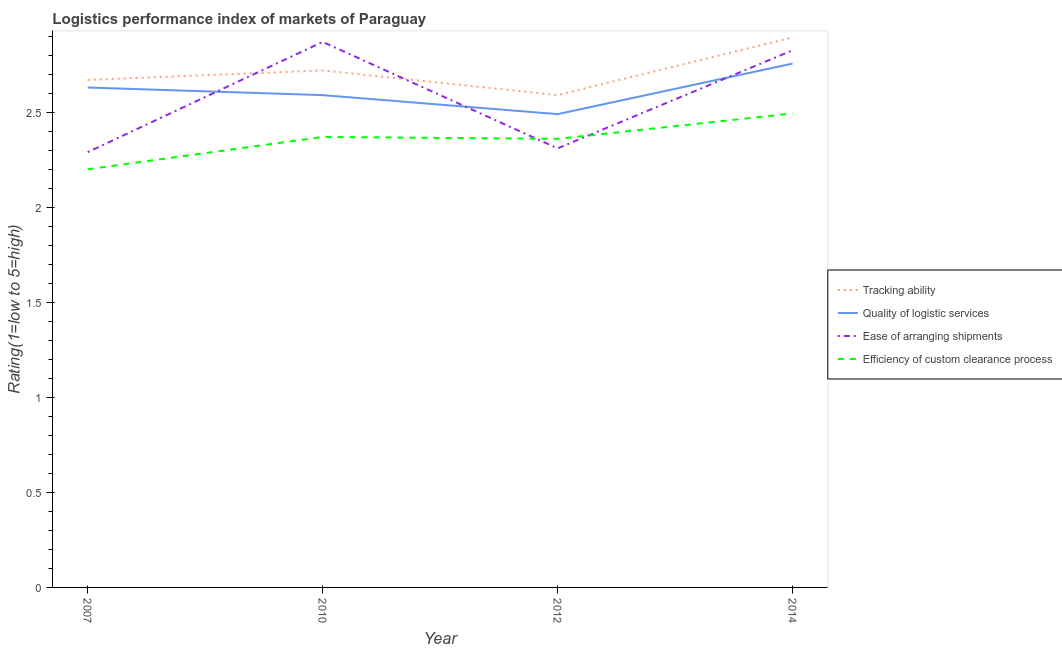Does the line corresponding to lpi rating of quality of logistic services intersect with the line corresponding to lpi rating of efficiency of custom clearance process?
Provide a succinct answer. No. What is the lpi rating of quality of logistic services in 2010?
Your answer should be very brief. 2.59. Across all years, what is the maximum lpi rating of efficiency of custom clearance process?
Your response must be concise. 2.49. Across all years, what is the minimum lpi rating of tracking ability?
Ensure brevity in your answer.  2.59. In which year was the lpi rating of ease of arranging shipments minimum?
Ensure brevity in your answer.  2007. What is the total lpi rating of quality of logistic services in the graph?
Your response must be concise. 10.47. What is the difference between the lpi rating of ease of arranging shipments in 2010 and that in 2014?
Offer a terse response. 0.04. What is the difference between the lpi rating of quality of logistic services in 2014 and the lpi rating of tracking ability in 2007?
Provide a succinct answer. 0.09. What is the average lpi rating of quality of logistic services per year?
Provide a succinct answer. 2.62. In the year 2007, what is the difference between the lpi rating of tracking ability and lpi rating of ease of arranging shipments?
Provide a short and direct response. 0.38. In how many years, is the lpi rating of efficiency of custom clearance process greater than 2.6?
Ensure brevity in your answer.  0. What is the ratio of the lpi rating of ease of arranging shipments in 2010 to that in 2012?
Make the answer very short. 1.24. What is the difference between the highest and the second highest lpi rating of ease of arranging shipments?
Ensure brevity in your answer.  0.04. What is the difference between the highest and the lowest lpi rating of ease of arranging shipments?
Your response must be concise. 0.58. In how many years, is the lpi rating of quality of logistic services greater than the average lpi rating of quality of logistic services taken over all years?
Offer a very short reply. 2. Does the lpi rating of quality of logistic services monotonically increase over the years?
Ensure brevity in your answer.  No. Is the lpi rating of ease of arranging shipments strictly less than the lpi rating of tracking ability over the years?
Offer a terse response. No. How many lines are there?
Provide a short and direct response. 4. What is the difference between two consecutive major ticks on the Y-axis?
Your answer should be compact. 0.5. Are the values on the major ticks of Y-axis written in scientific E-notation?
Make the answer very short. No. Where does the legend appear in the graph?
Offer a very short reply. Center right. What is the title of the graph?
Offer a terse response. Logistics performance index of markets of Paraguay. What is the label or title of the Y-axis?
Provide a succinct answer. Rating(1=low to 5=high). What is the Rating(1=low to 5=high) in Tracking ability in 2007?
Make the answer very short. 2.67. What is the Rating(1=low to 5=high) of Quality of logistic services in 2007?
Offer a very short reply. 2.63. What is the Rating(1=low to 5=high) of Ease of arranging shipments in 2007?
Your answer should be compact. 2.29. What is the Rating(1=low to 5=high) of Efficiency of custom clearance process in 2007?
Keep it short and to the point. 2.2. What is the Rating(1=low to 5=high) of Tracking ability in 2010?
Your answer should be very brief. 2.72. What is the Rating(1=low to 5=high) in Quality of logistic services in 2010?
Make the answer very short. 2.59. What is the Rating(1=low to 5=high) in Ease of arranging shipments in 2010?
Provide a short and direct response. 2.87. What is the Rating(1=low to 5=high) of Efficiency of custom clearance process in 2010?
Ensure brevity in your answer.  2.37. What is the Rating(1=low to 5=high) in Tracking ability in 2012?
Provide a short and direct response. 2.59. What is the Rating(1=low to 5=high) of Quality of logistic services in 2012?
Offer a terse response. 2.49. What is the Rating(1=low to 5=high) in Ease of arranging shipments in 2012?
Provide a short and direct response. 2.31. What is the Rating(1=low to 5=high) in Efficiency of custom clearance process in 2012?
Make the answer very short. 2.36. What is the Rating(1=low to 5=high) of Tracking ability in 2014?
Keep it short and to the point. 2.89. What is the Rating(1=low to 5=high) in Quality of logistic services in 2014?
Your response must be concise. 2.76. What is the Rating(1=low to 5=high) of Ease of arranging shipments in 2014?
Your answer should be compact. 2.83. What is the Rating(1=low to 5=high) in Efficiency of custom clearance process in 2014?
Keep it short and to the point. 2.49. Across all years, what is the maximum Rating(1=low to 5=high) of Tracking ability?
Keep it short and to the point. 2.89. Across all years, what is the maximum Rating(1=low to 5=high) in Quality of logistic services?
Give a very brief answer. 2.76. Across all years, what is the maximum Rating(1=low to 5=high) in Ease of arranging shipments?
Ensure brevity in your answer.  2.87. Across all years, what is the maximum Rating(1=low to 5=high) in Efficiency of custom clearance process?
Provide a succinct answer. 2.49. Across all years, what is the minimum Rating(1=low to 5=high) of Tracking ability?
Provide a short and direct response. 2.59. Across all years, what is the minimum Rating(1=low to 5=high) of Quality of logistic services?
Provide a short and direct response. 2.49. Across all years, what is the minimum Rating(1=low to 5=high) of Ease of arranging shipments?
Your answer should be compact. 2.29. What is the total Rating(1=low to 5=high) in Tracking ability in the graph?
Provide a succinct answer. 10.87. What is the total Rating(1=low to 5=high) in Quality of logistic services in the graph?
Provide a short and direct response. 10.47. What is the total Rating(1=low to 5=high) in Ease of arranging shipments in the graph?
Your response must be concise. 10.3. What is the total Rating(1=low to 5=high) in Efficiency of custom clearance process in the graph?
Your answer should be very brief. 9.42. What is the difference between the Rating(1=low to 5=high) of Tracking ability in 2007 and that in 2010?
Ensure brevity in your answer.  -0.05. What is the difference between the Rating(1=low to 5=high) of Quality of logistic services in 2007 and that in 2010?
Give a very brief answer. 0.04. What is the difference between the Rating(1=low to 5=high) of Ease of arranging shipments in 2007 and that in 2010?
Your response must be concise. -0.58. What is the difference between the Rating(1=low to 5=high) of Efficiency of custom clearance process in 2007 and that in 2010?
Your answer should be very brief. -0.17. What is the difference between the Rating(1=low to 5=high) of Quality of logistic services in 2007 and that in 2012?
Your answer should be very brief. 0.14. What is the difference between the Rating(1=low to 5=high) of Ease of arranging shipments in 2007 and that in 2012?
Keep it short and to the point. -0.02. What is the difference between the Rating(1=low to 5=high) of Efficiency of custom clearance process in 2007 and that in 2012?
Ensure brevity in your answer.  -0.16. What is the difference between the Rating(1=low to 5=high) in Tracking ability in 2007 and that in 2014?
Give a very brief answer. -0.22. What is the difference between the Rating(1=low to 5=high) in Quality of logistic services in 2007 and that in 2014?
Provide a succinct answer. -0.13. What is the difference between the Rating(1=low to 5=high) in Ease of arranging shipments in 2007 and that in 2014?
Offer a very short reply. -0.54. What is the difference between the Rating(1=low to 5=high) of Efficiency of custom clearance process in 2007 and that in 2014?
Offer a terse response. -0.29. What is the difference between the Rating(1=low to 5=high) of Tracking ability in 2010 and that in 2012?
Keep it short and to the point. 0.13. What is the difference between the Rating(1=low to 5=high) in Ease of arranging shipments in 2010 and that in 2012?
Your answer should be compact. 0.56. What is the difference between the Rating(1=low to 5=high) of Efficiency of custom clearance process in 2010 and that in 2012?
Keep it short and to the point. 0.01. What is the difference between the Rating(1=low to 5=high) in Tracking ability in 2010 and that in 2014?
Your response must be concise. -0.17. What is the difference between the Rating(1=low to 5=high) in Quality of logistic services in 2010 and that in 2014?
Keep it short and to the point. -0.17. What is the difference between the Rating(1=low to 5=high) of Ease of arranging shipments in 2010 and that in 2014?
Your response must be concise. 0.04. What is the difference between the Rating(1=low to 5=high) of Efficiency of custom clearance process in 2010 and that in 2014?
Offer a very short reply. -0.12. What is the difference between the Rating(1=low to 5=high) of Tracking ability in 2012 and that in 2014?
Offer a very short reply. -0.3. What is the difference between the Rating(1=low to 5=high) in Quality of logistic services in 2012 and that in 2014?
Your answer should be very brief. -0.27. What is the difference between the Rating(1=low to 5=high) of Ease of arranging shipments in 2012 and that in 2014?
Provide a succinct answer. -0.52. What is the difference between the Rating(1=low to 5=high) in Efficiency of custom clearance process in 2012 and that in 2014?
Ensure brevity in your answer.  -0.13. What is the difference between the Rating(1=low to 5=high) of Tracking ability in 2007 and the Rating(1=low to 5=high) of Efficiency of custom clearance process in 2010?
Give a very brief answer. 0.3. What is the difference between the Rating(1=low to 5=high) of Quality of logistic services in 2007 and the Rating(1=low to 5=high) of Ease of arranging shipments in 2010?
Give a very brief answer. -0.24. What is the difference between the Rating(1=low to 5=high) of Quality of logistic services in 2007 and the Rating(1=low to 5=high) of Efficiency of custom clearance process in 2010?
Ensure brevity in your answer.  0.26. What is the difference between the Rating(1=low to 5=high) in Ease of arranging shipments in 2007 and the Rating(1=low to 5=high) in Efficiency of custom clearance process in 2010?
Give a very brief answer. -0.08. What is the difference between the Rating(1=low to 5=high) of Tracking ability in 2007 and the Rating(1=low to 5=high) of Quality of logistic services in 2012?
Your answer should be compact. 0.18. What is the difference between the Rating(1=low to 5=high) in Tracking ability in 2007 and the Rating(1=low to 5=high) in Ease of arranging shipments in 2012?
Your answer should be compact. 0.36. What is the difference between the Rating(1=low to 5=high) of Tracking ability in 2007 and the Rating(1=low to 5=high) of Efficiency of custom clearance process in 2012?
Make the answer very short. 0.31. What is the difference between the Rating(1=low to 5=high) of Quality of logistic services in 2007 and the Rating(1=low to 5=high) of Ease of arranging shipments in 2012?
Offer a terse response. 0.32. What is the difference between the Rating(1=low to 5=high) of Quality of logistic services in 2007 and the Rating(1=low to 5=high) of Efficiency of custom clearance process in 2012?
Offer a very short reply. 0.27. What is the difference between the Rating(1=low to 5=high) of Ease of arranging shipments in 2007 and the Rating(1=low to 5=high) of Efficiency of custom clearance process in 2012?
Your answer should be very brief. -0.07. What is the difference between the Rating(1=low to 5=high) in Tracking ability in 2007 and the Rating(1=low to 5=high) in Quality of logistic services in 2014?
Provide a succinct answer. -0.09. What is the difference between the Rating(1=low to 5=high) in Tracking ability in 2007 and the Rating(1=low to 5=high) in Ease of arranging shipments in 2014?
Your response must be concise. -0.16. What is the difference between the Rating(1=low to 5=high) in Tracking ability in 2007 and the Rating(1=low to 5=high) in Efficiency of custom clearance process in 2014?
Provide a succinct answer. 0.18. What is the difference between the Rating(1=low to 5=high) of Quality of logistic services in 2007 and the Rating(1=low to 5=high) of Ease of arranging shipments in 2014?
Keep it short and to the point. -0.2. What is the difference between the Rating(1=low to 5=high) of Quality of logistic services in 2007 and the Rating(1=low to 5=high) of Efficiency of custom clearance process in 2014?
Offer a terse response. 0.14. What is the difference between the Rating(1=low to 5=high) in Ease of arranging shipments in 2007 and the Rating(1=low to 5=high) in Efficiency of custom clearance process in 2014?
Offer a very short reply. -0.2. What is the difference between the Rating(1=low to 5=high) in Tracking ability in 2010 and the Rating(1=low to 5=high) in Quality of logistic services in 2012?
Your answer should be compact. 0.23. What is the difference between the Rating(1=low to 5=high) in Tracking ability in 2010 and the Rating(1=low to 5=high) in Ease of arranging shipments in 2012?
Make the answer very short. 0.41. What is the difference between the Rating(1=low to 5=high) of Tracking ability in 2010 and the Rating(1=low to 5=high) of Efficiency of custom clearance process in 2012?
Offer a very short reply. 0.36. What is the difference between the Rating(1=low to 5=high) of Quality of logistic services in 2010 and the Rating(1=low to 5=high) of Ease of arranging shipments in 2012?
Provide a short and direct response. 0.28. What is the difference between the Rating(1=low to 5=high) in Quality of logistic services in 2010 and the Rating(1=low to 5=high) in Efficiency of custom clearance process in 2012?
Offer a very short reply. 0.23. What is the difference between the Rating(1=low to 5=high) in Ease of arranging shipments in 2010 and the Rating(1=low to 5=high) in Efficiency of custom clearance process in 2012?
Provide a succinct answer. 0.51. What is the difference between the Rating(1=low to 5=high) of Tracking ability in 2010 and the Rating(1=low to 5=high) of Quality of logistic services in 2014?
Your response must be concise. -0.04. What is the difference between the Rating(1=low to 5=high) of Tracking ability in 2010 and the Rating(1=low to 5=high) of Ease of arranging shipments in 2014?
Make the answer very short. -0.11. What is the difference between the Rating(1=low to 5=high) in Tracking ability in 2010 and the Rating(1=low to 5=high) in Efficiency of custom clearance process in 2014?
Your response must be concise. 0.23. What is the difference between the Rating(1=low to 5=high) in Quality of logistic services in 2010 and the Rating(1=low to 5=high) in Ease of arranging shipments in 2014?
Provide a short and direct response. -0.24. What is the difference between the Rating(1=low to 5=high) in Quality of logistic services in 2010 and the Rating(1=low to 5=high) in Efficiency of custom clearance process in 2014?
Ensure brevity in your answer.  0.1. What is the difference between the Rating(1=low to 5=high) in Ease of arranging shipments in 2010 and the Rating(1=low to 5=high) in Efficiency of custom clearance process in 2014?
Ensure brevity in your answer.  0.38. What is the difference between the Rating(1=low to 5=high) of Tracking ability in 2012 and the Rating(1=low to 5=high) of Quality of logistic services in 2014?
Ensure brevity in your answer.  -0.17. What is the difference between the Rating(1=low to 5=high) in Tracking ability in 2012 and the Rating(1=low to 5=high) in Ease of arranging shipments in 2014?
Give a very brief answer. -0.24. What is the difference between the Rating(1=low to 5=high) in Tracking ability in 2012 and the Rating(1=low to 5=high) in Efficiency of custom clearance process in 2014?
Keep it short and to the point. 0.1. What is the difference between the Rating(1=low to 5=high) in Quality of logistic services in 2012 and the Rating(1=low to 5=high) in Ease of arranging shipments in 2014?
Offer a terse response. -0.34. What is the difference between the Rating(1=low to 5=high) in Quality of logistic services in 2012 and the Rating(1=low to 5=high) in Efficiency of custom clearance process in 2014?
Offer a terse response. -0. What is the difference between the Rating(1=low to 5=high) of Ease of arranging shipments in 2012 and the Rating(1=low to 5=high) of Efficiency of custom clearance process in 2014?
Offer a terse response. -0.18. What is the average Rating(1=low to 5=high) of Tracking ability per year?
Your answer should be very brief. 2.72. What is the average Rating(1=low to 5=high) in Quality of logistic services per year?
Your response must be concise. 2.62. What is the average Rating(1=low to 5=high) of Ease of arranging shipments per year?
Provide a succinct answer. 2.57. What is the average Rating(1=low to 5=high) in Efficiency of custom clearance process per year?
Keep it short and to the point. 2.36. In the year 2007, what is the difference between the Rating(1=low to 5=high) in Tracking ability and Rating(1=low to 5=high) in Quality of logistic services?
Ensure brevity in your answer.  0.04. In the year 2007, what is the difference between the Rating(1=low to 5=high) in Tracking ability and Rating(1=low to 5=high) in Ease of arranging shipments?
Your response must be concise. 0.38. In the year 2007, what is the difference between the Rating(1=low to 5=high) of Tracking ability and Rating(1=low to 5=high) of Efficiency of custom clearance process?
Keep it short and to the point. 0.47. In the year 2007, what is the difference between the Rating(1=low to 5=high) of Quality of logistic services and Rating(1=low to 5=high) of Ease of arranging shipments?
Make the answer very short. 0.34. In the year 2007, what is the difference between the Rating(1=low to 5=high) of Quality of logistic services and Rating(1=low to 5=high) of Efficiency of custom clearance process?
Offer a terse response. 0.43. In the year 2007, what is the difference between the Rating(1=low to 5=high) of Ease of arranging shipments and Rating(1=low to 5=high) of Efficiency of custom clearance process?
Provide a short and direct response. 0.09. In the year 2010, what is the difference between the Rating(1=low to 5=high) in Tracking ability and Rating(1=low to 5=high) in Quality of logistic services?
Offer a very short reply. 0.13. In the year 2010, what is the difference between the Rating(1=low to 5=high) in Tracking ability and Rating(1=low to 5=high) in Efficiency of custom clearance process?
Ensure brevity in your answer.  0.35. In the year 2010, what is the difference between the Rating(1=low to 5=high) of Quality of logistic services and Rating(1=low to 5=high) of Ease of arranging shipments?
Offer a terse response. -0.28. In the year 2010, what is the difference between the Rating(1=low to 5=high) in Quality of logistic services and Rating(1=low to 5=high) in Efficiency of custom clearance process?
Offer a terse response. 0.22. In the year 2012, what is the difference between the Rating(1=low to 5=high) of Tracking ability and Rating(1=low to 5=high) of Quality of logistic services?
Your answer should be compact. 0.1. In the year 2012, what is the difference between the Rating(1=low to 5=high) of Tracking ability and Rating(1=low to 5=high) of Ease of arranging shipments?
Give a very brief answer. 0.28. In the year 2012, what is the difference between the Rating(1=low to 5=high) of Tracking ability and Rating(1=low to 5=high) of Efficiency of custom clearance process?
Provide a succinct answer. 0.23. In the year 2012, what is the difference between the Rating(1=low to 5=high) in Quality of logistic services and Rating(1=low to 5=high) in Ease of arranging shipments?
Your answer should be compact. 0.18. In the year 2012, what is the difference between the Rating(1=low to 5=high) of Quality of logistic services and Rating(1=low to 5=high) of Efficiency of custom clearance process?
Give a very brief answer. 0.13. In the year 2012, what is the difference between the Rating(1=low to 5=high) of Ease of arranging shipments and Rating(1=low to 5=high) of Efficiency of custom clearance process?
Give a very brief answer. -0.05. In the year 2014, what is the difference between the Rating(1=low to 5=high) in Tracking ability and Rating(1=low to 5=high) in Quality of logistic services?
Offer a terse response. 0.14. In the year 2014, what is the difference between the Rating(1=low to 5=high) in Tracking ability and Rating(1=low to 5=high) in Ease of arranging shipments?
Offer a very short reply. 0.07. In the year 2014, what is the difference between the Rating(1=low to 5=high) in Quality of logistic services and Rating(1=low to 5=high) in Ease of arranging shipments?
Give a very brief answer. -0.07. In the year 2014, what is the difference between the Rating(1=low to 5=high) of Quality of logistic services and Rating(1=low to 5=high) of Efficiency of custom clearance process?
Your answer should be compact. 0.26. In the year 2014, what is the difference between the Rating(1=low to 5=high) of Ease of arranging shipments and Rating(1=low to 5=high) of Efficiency of custom clearance process?
Make the answer very short. 0.33. What is the ratio of the Rating(1=low to 5=high) in Tracking ability in 2007 to that in 2010?
Provide a succinct answer. 0.98. What is the ratio of the Rating(1=low to 5=high) in Quality of logistic services in 2007 to that in 2010?
Provide a succinct answer. 1.02. What is the ratio of the Rating(1=low to 5=high) of Ease of arranging shipments in 2007 to that in 2010?
Keep it short and to the point. 0.8. What is the ratio of the Rating(1=low to 5=high) in Efficiency of custom clearance process in 2007 to that in 2010?
Keep it short and to the point. 0.93. What is the ratio of the Rating(1=low to 5=high) in Tracking ability in 2007 to that in 2012?
Provide a succinct answer. 1.03. What is the ratio of the Rating(1=low to 5=high) of Quality of logistic services in 2007 to that in 2012?
Provide a short and direct response. 1.06. What is the ratio of the Rating(1=low to 5=high) in Efficiency of custom clearance process in 2007 to that in 2012?
Your answer should be compact. 0.93. What is the ratio of the Rating(1=low to 5=high) of Tracking ability in 2007 to that in 2014?
Make the answer very short. 0.92. What is the ratio of the Rating(1=low to 5=high) in Quality of logistic services in 2007 to that in 2014?
Ensure brevity in your answer.  0.95. What is the ratio of the Rating(1=low to 5=high) in Ease of arranging shipments in 2007 to that in 2014?
Offer a terse response. 0.81. What is the ratio of the Rating(1=low to 5=high) of Efficiency of custom clearance process in 2007 to that in 2014?
Keep it short and to the point. 0.88. What is the ratio of the Rating(1=low to 5=high) in Tracking ability in 2010 to that in 2012?
Provide a short and direct response. 1.05. What is the ratio of the Rating(1=low to 5=high) of Quality of logistic services in 2010 to that in 2012?
Your response must be concise. 1.04. What is the ratio of the Rating(1=low to 5=high) of Ease of arranging shipments in 2010 to that in 2012?
Offer a terse response. 1.24. What is the ratio of the Rating(1=low to 5=high) in Efficiency of custom clearance process in 2010 to that in 2012?
Provide a short and direct response. 1. What is the ratio of the Rating(1=low to 5=high) in Quality of logistic services in 2010 to that in 2014?
Keep it short and to the point. 0.94. What is the ratio of the Rating(1=low to 5=high) of Ease of arranging shipments in 2010 to that in 2014?
Provide a succinct answer. 1.02. What is the ratio of the Rating(1=low to 5=high) of Efficiency of custom clearance process in 2010 to that in 2014?
Provide a succinct answer. 0.95. What is the ratio of the Rating(1=low to 5=high) in Tracking ability in 2012 to that in 2014?
Offer a very short reply. 0.9. What is the ratio of the Rating(1=low to 5=high) in Quality of logistic services in 2012 to that in 2014?
Provide a short and direct response. 0.9. What is the ratio of the Rating(1=low to 5=high) in Ease of arranging shipments in 2012 to that in 2014?
Your response must be concise. 0.82. What is the ratio of the Rating(1=low to 5=high) of Efficiency of custom clearance process in 2012 to that in 2014?
Ensure brevity in your answer.  0.95. What is the difference between the highest and the second highest Rating(1=low to 5=high) in Tracking ability?
Provide a succinct answer. 0.17. What is the difference between the highest and the second highest Rating(1=low to 5=high) in Quality of logistic services?
Your answer should be very brief. 0.13. What is the difference between the highest and the second highest Rating(1=low to 5=high) in Ease of arranging shipments?
Your response must be concise. 0.04. What is the difference between the highest and the second highest Rating(1=low to 5=high) in Efficiency of custom clearance process?
Make the answer very short. 0.12. What is the difference between the highest and the lowest Rating(1=low to 5=high) in Tracking ability?
Offer a very short reply. 0.3. What is the difference between the highest and the lowest Rating(1=low to 5=high) in Quality of logistic services?
Provide a succinct answer. 0.27. What is the difference between the highest and the lowest Rating(1=low to 5=high) in Ease of arranging shipments?
Your answer should be very brief. 0.58. What is the difference between the highest and the lowest Rating(1=low to 5=high) in Efficiency of custom clearance process?
Make the answer very short. 0.29. 